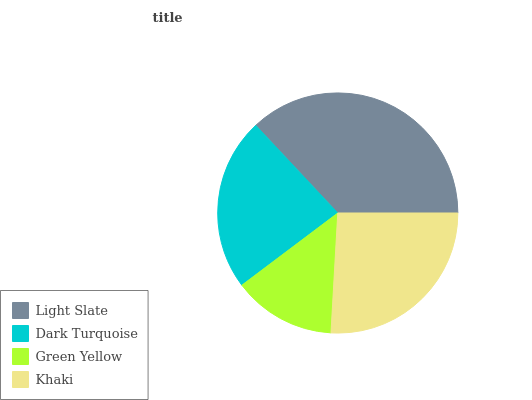Is Green Yellow the minimum?
Answer yes or no. Yes. Is Light Slate the maximum?
Answer yes or no. Yes. Is Dark Turquoise the minimum?
Answer yes or no. No. Is Dark Turquoise the maximum?
Answer yes or no. No. Is Light Slate greater than Dark Turquoise?
Answer yes or no. Yes. Is Dark Turquoise less than Light Slate?
Answer yes or no. Yes. Is Dark Turquoise greater than Light Slate?
Answer yes or no. No. Is Light Slate less than Dark Turquoise?
Answer yes or no. No. Is Khaki the high median?
Answer yes or no. Yes. Is Dark Turquoise the low median?
Answer yes or no. Yes. Is Green Yellow the high median?
Answer yes or no. No. Is Green Yellow the low median?
Answer yes or no. No. 